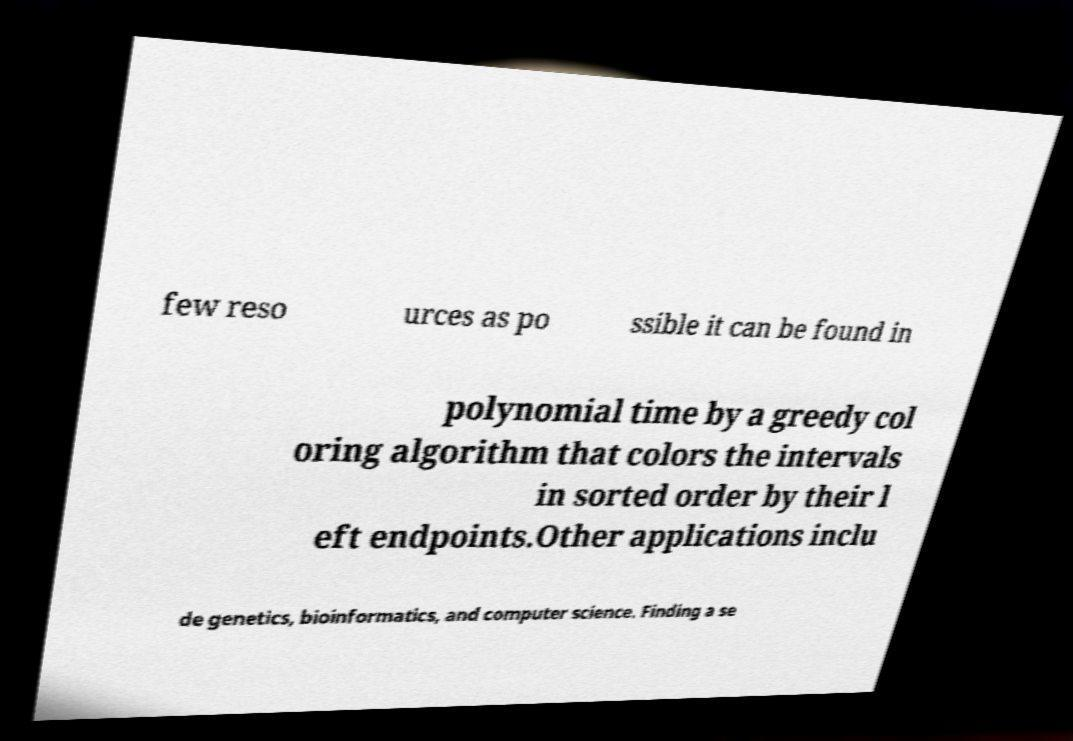I need the written content from this picture converted into text. Can you do that? few reso urces as po ssible it can be found in polynomial time by a greedy col oring algorithm that colors the intervals in sorted order by their l eft endpoints.Other applications inclu de genetics, bioinformatics, and computer science. Finding a se 